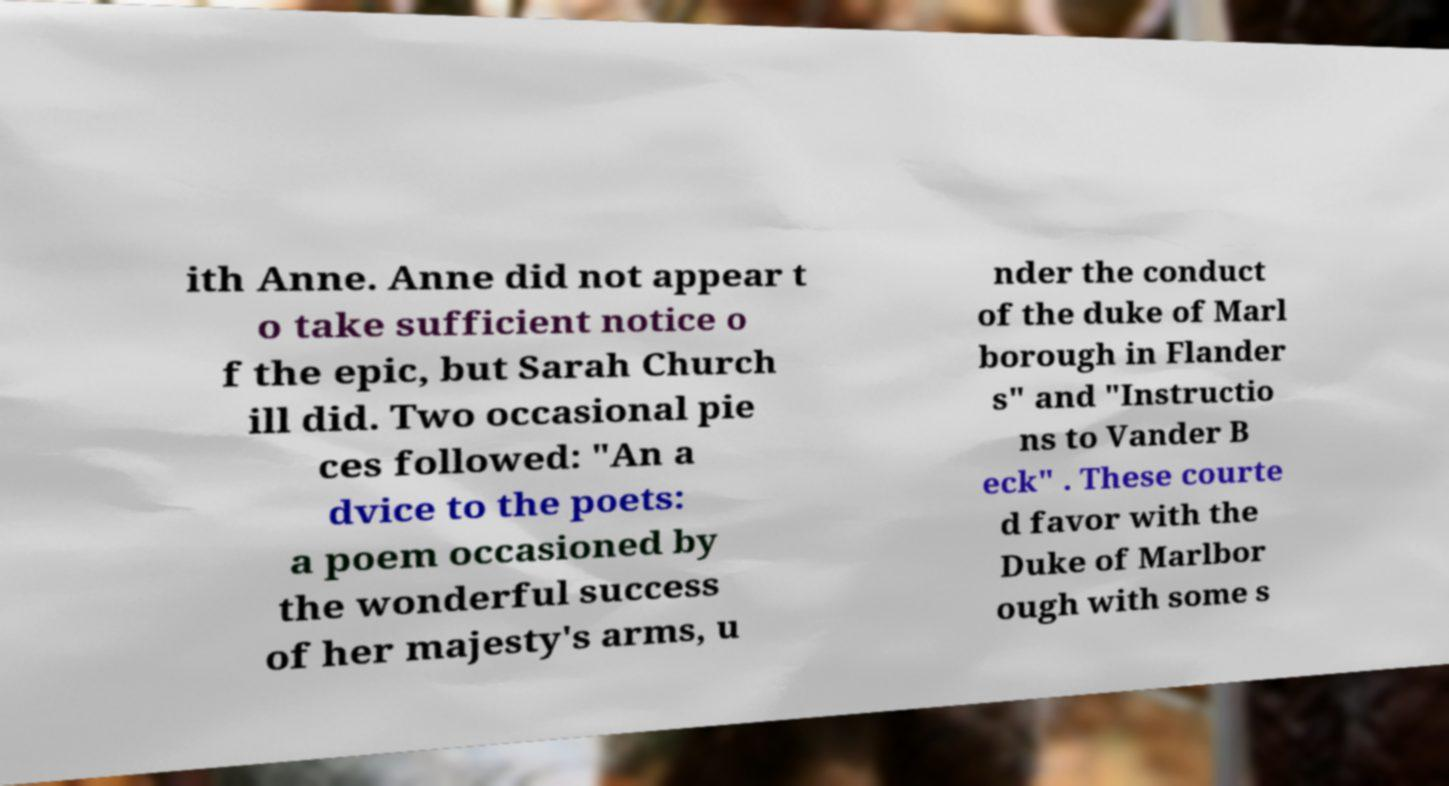What messages or text are displayed in this image? I need them in a readable, typed format. ith Anne. Anne did not appear t o take sufficient notice o f the epic, but Sarah Church ill did. Two occasional pie ces followed: "An a dvice to the poets: a poem occasioned by the wonderful success of her majesty's arms, u nder the conduct of the duke of Marl borough in Flander s" and "Instructio ns to Vander B eck" . These courte d favor with the Duke of Marlbor ough with some s 